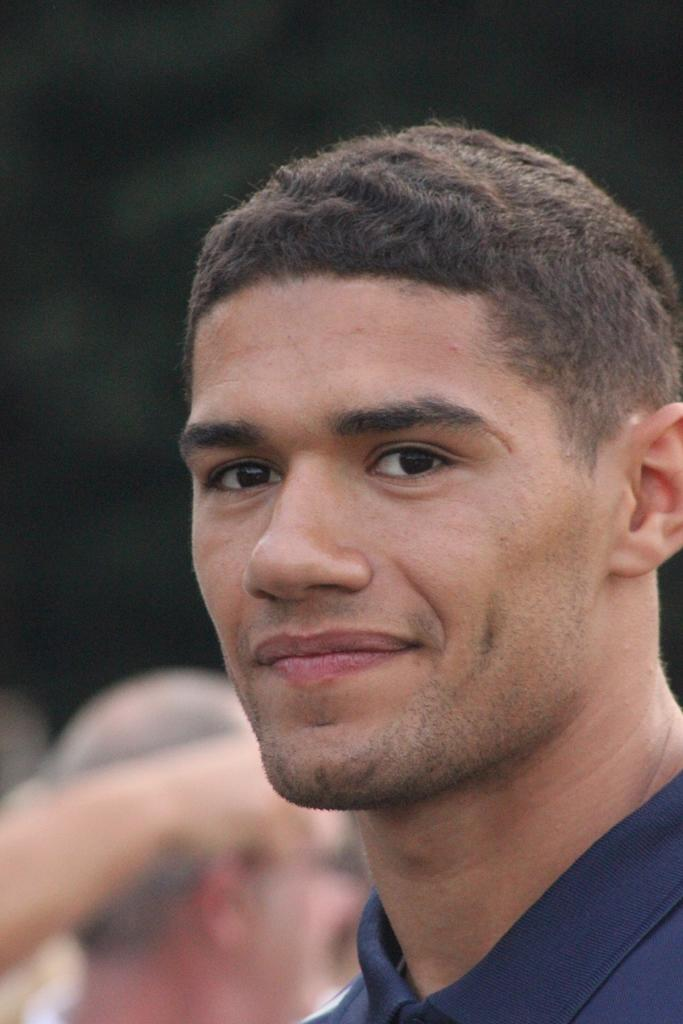Who is in the image? There is a man in the image. What is the man doing in the image? The man is smiling in the image. Can you describe the background of the image? The background of the image is blurred. What type of point is the man making in the image? There is no indication in the image that the man is making any point; he is simply smiling. 